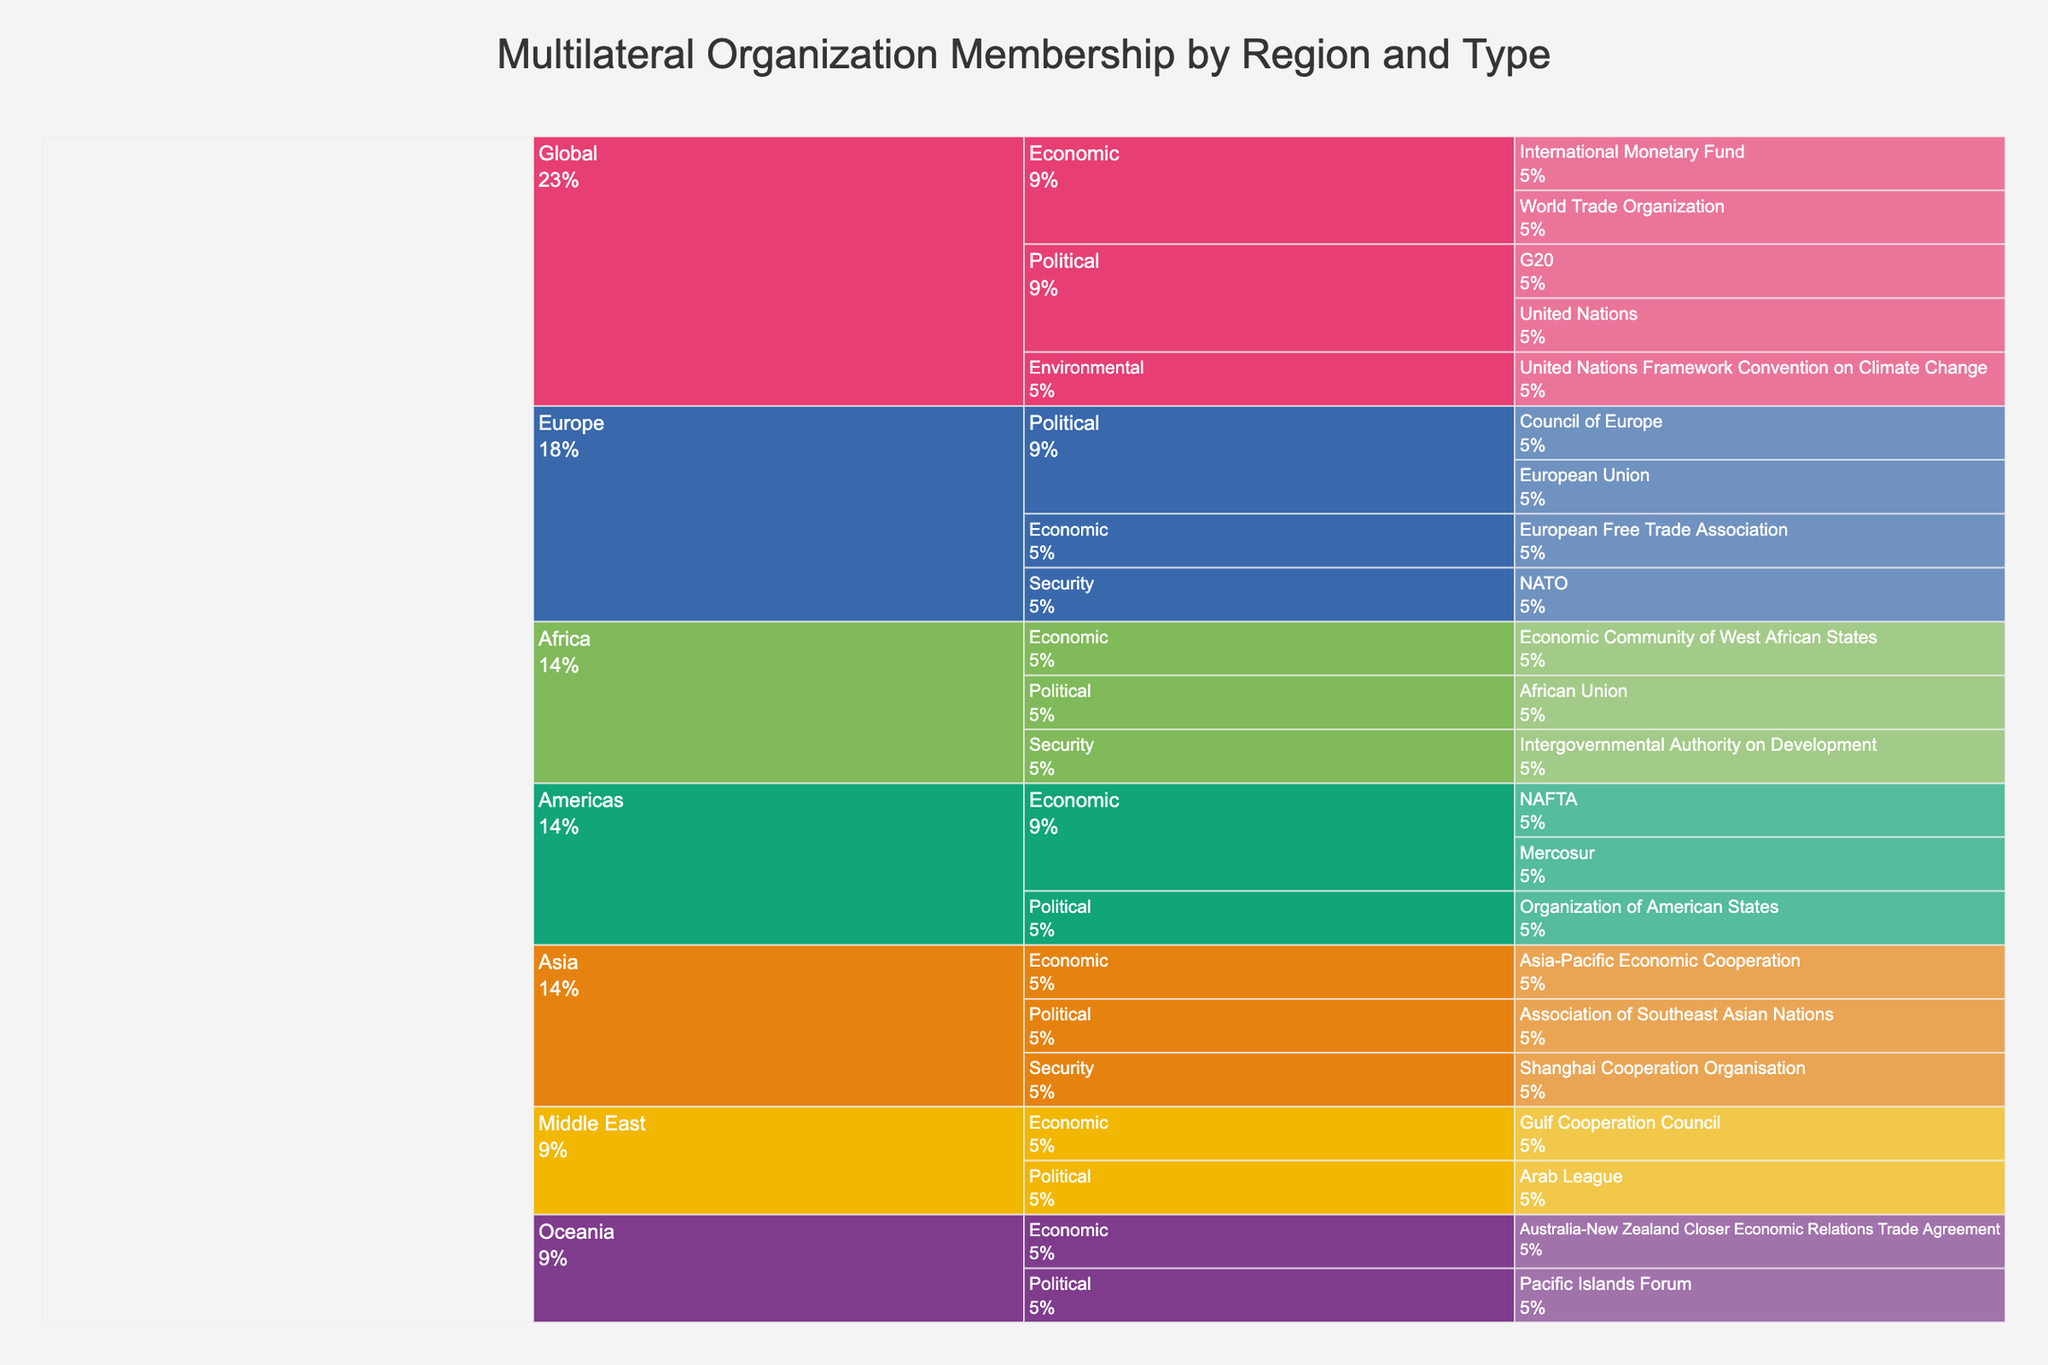What is the title of the icicle chart? The title is placed at the top of the chart and is usually in a larger font size to indicate the main topic or theme of the visualization.
Answer: Multilateral Organization Membership by Region and Type What types of organizations are included in the Middle East region? Look for the Middle East section in the icicle chart and observe the branches under it, which indicate different organization types.
Answer: Political, Economic Which region has the most diverse range of organization types? Analyze each region in the icicle chart and count the different types of organizations they have.
Answer: Asia How many economic organizations are represented in the Americas region? Find the Americas section, then look for the sub-branch labeled Economic. Count the organizations listed under this branch.
Answer: 2 Which region is associated with the United Nations Framework Convention on Climate Change? Trace the path starting from the organization to its parent categories until reaching the region label.
Answer: Global How does the number of political organizations in Africa compare to those in Europe? Count the political organizations listed under the Africa and Europe sections, then compare the totals.
Answer: Africa: 1, Europe: 2 Which region has organizations related to security, and how many such organizations are there in that region? Identify regions with Security branches and count the organizations listed under each.
Answer: Europe: 1, Asia: 1, Africa: 1 What is the total number of organizations represented globally across all regions? Sum up the individual organizations listed under each region's branches.
Answer: 22 Of the organizations listed, which one falls under the Oceania region and the Economic type? Locate the Oceania section, find the Economic sub-branch, and read the organization listed under it.
Answer: Australia-New Zealand Closer Economic Relations Trade Agreement 